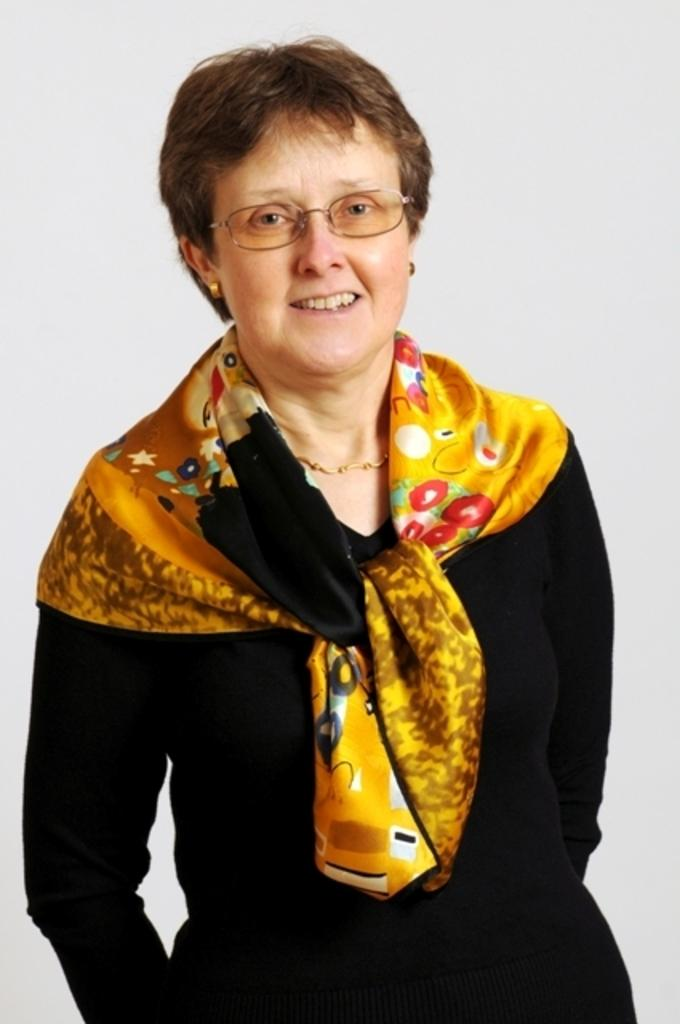Who is the main subject in the image? There is a woman in the image. What is the woman doing in the image? The woman is standing. What is the woman wearing on her face? The woman is wearing spectacles. What is the woman wearing on her body? The woman is wearing a cloth. What is the woman's facial expression in the image? The woman has a smile on her face. What is the color of the background in the image? The background of the image is white. How much money is the woman holding in the image? There is no indication of money in the image; the woman is not holding any. What type of clam is the woman holding in the image? There is no clam present in the image; the woman is not holding any. 